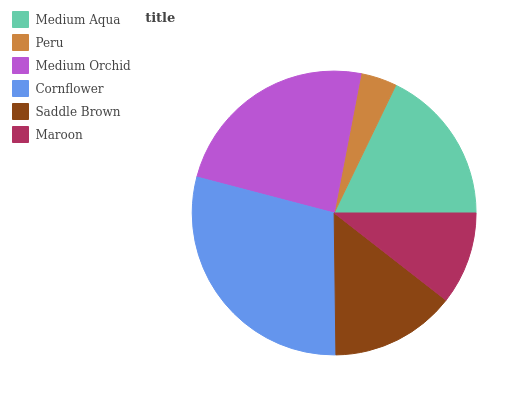Is Peru the minimum?
Answer yes or no. Yes. Is Cornflower the maximum?
Answer yes or no. Yes. Is Medium Orchid the minimum?
Answer yes or no. No. Is Medium Orchid the maximum?
Answer yes or no. No. Is Medium Orchid greater than Peru?
Answer yes or no. Yes. Is Peru less than Medium Orchid?
Answer yes or no. Yes. Is Peru greater than Medium Orchid?
Answer yes or no. No. Is Medium Orchid less than Peru?
Answer yes or no. No. Is Medium Aqua the high median?
Answer yes or no. Yes. Is Saddle Brown the low median?
Answer yes or no. Yes. Is Cornflower the high median?
Answer yes or no. No. Is Medium Aqua the low median?
Answer yes or no. No. 